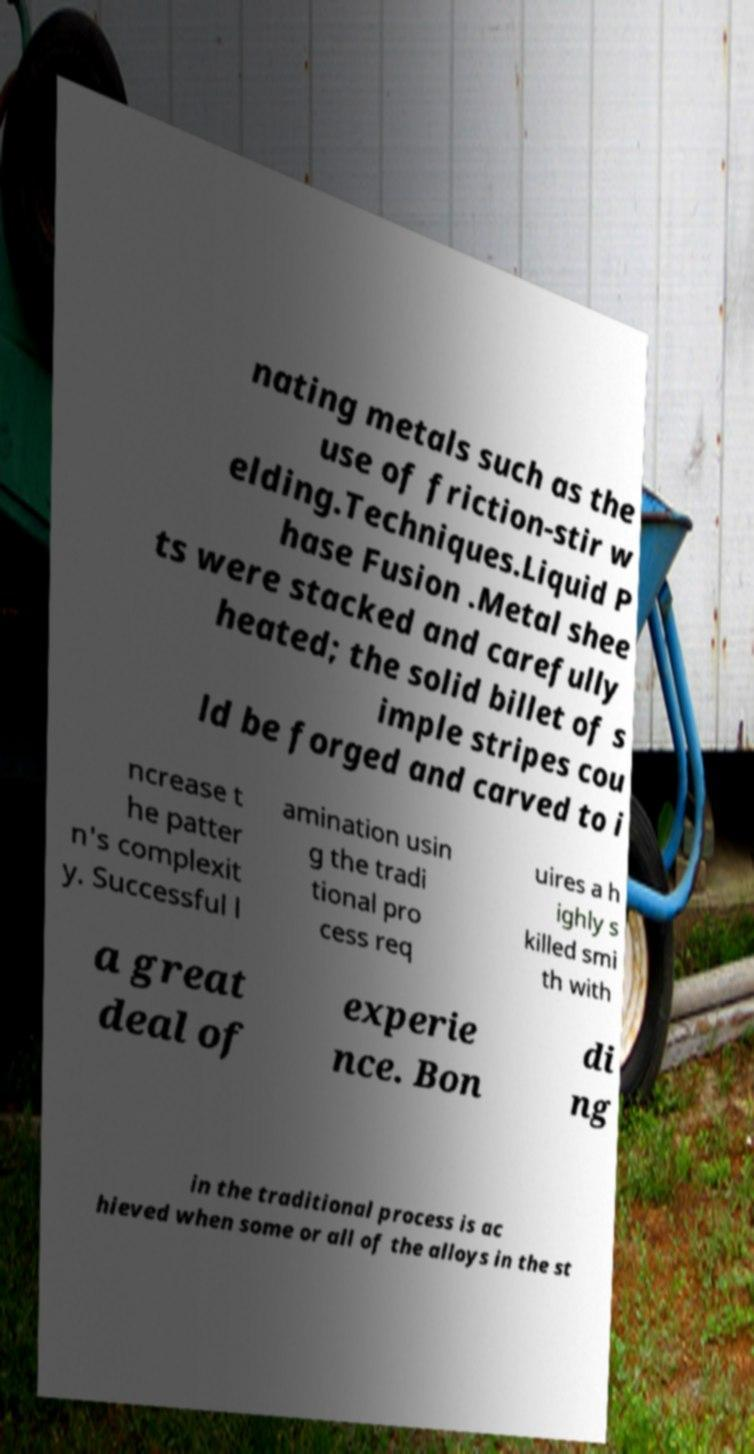Could you extract and type out the text from this image? nating metals such as the use of friction-stir w elding.Techniques.Liquid P hase Fusion .Metal shee ts were stacked and carefully heated; the solid billet of s imple stripes cou ld be forged and carved to i ncrease t he patter n's complexit y. Successful l amination usin g the tradi tional pro cess req uires a h ighly s killed smi th with a great deal of experie nce. Bon di ng in the traditional process is ac hieved when some or all of the alloys in the st 